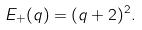Convert formula to latex. <formula><loc_0><loc_0><loc_500><loc_500>E _ { + } ( q ) = ( q + 2 ) ^ { 2 } .</formula> 